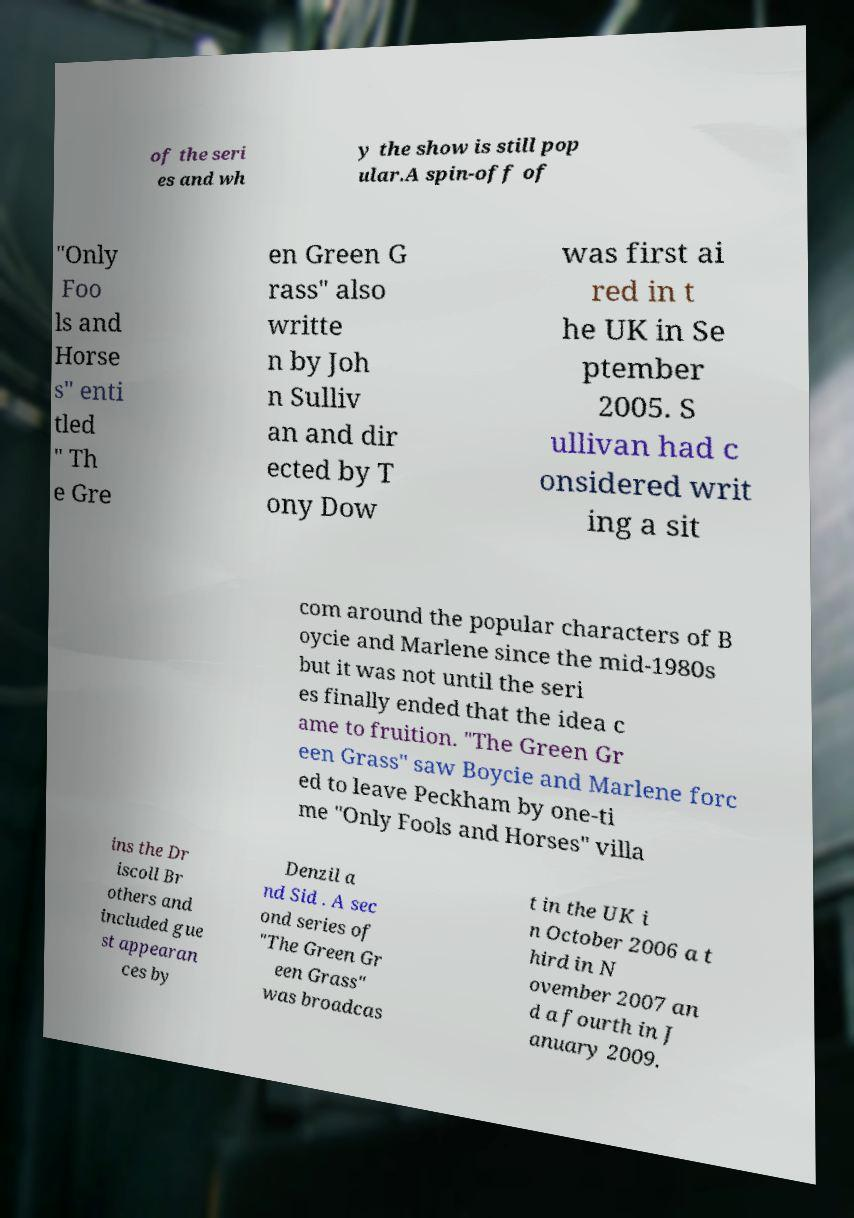Could you extract and type out the text from this image? of the seri es and wh y the show is still pop ular.A spin-off of "Only Foo ls and Horse s" enti tled " Th e Gre en Green G rass" also writte n by Joh n Sulliv an and dir ected by T ony Dow was first ai red in t he UK in Se ptember 2005. S ullivan had c onsidered writ ing a sit com around the popular characters of B oycie and Marlene since the mid-1980s but it was not until the seri es finally ended that the idea c ame to fruition. "The Green Gr een Grass" saw Boycie and Marlene forc ed to leave Peckham by one-ti me "Only Fools and Horses" villa ins the Dr iscoll Br others and included gue st appearan ces by Denzil a nd Sid . A sec ond series of "The Green Gr een Grass" was broadcas t in the UK i n October 2006 a t hird in N ovember 2007 an d a fourth in J anuary 2009. 